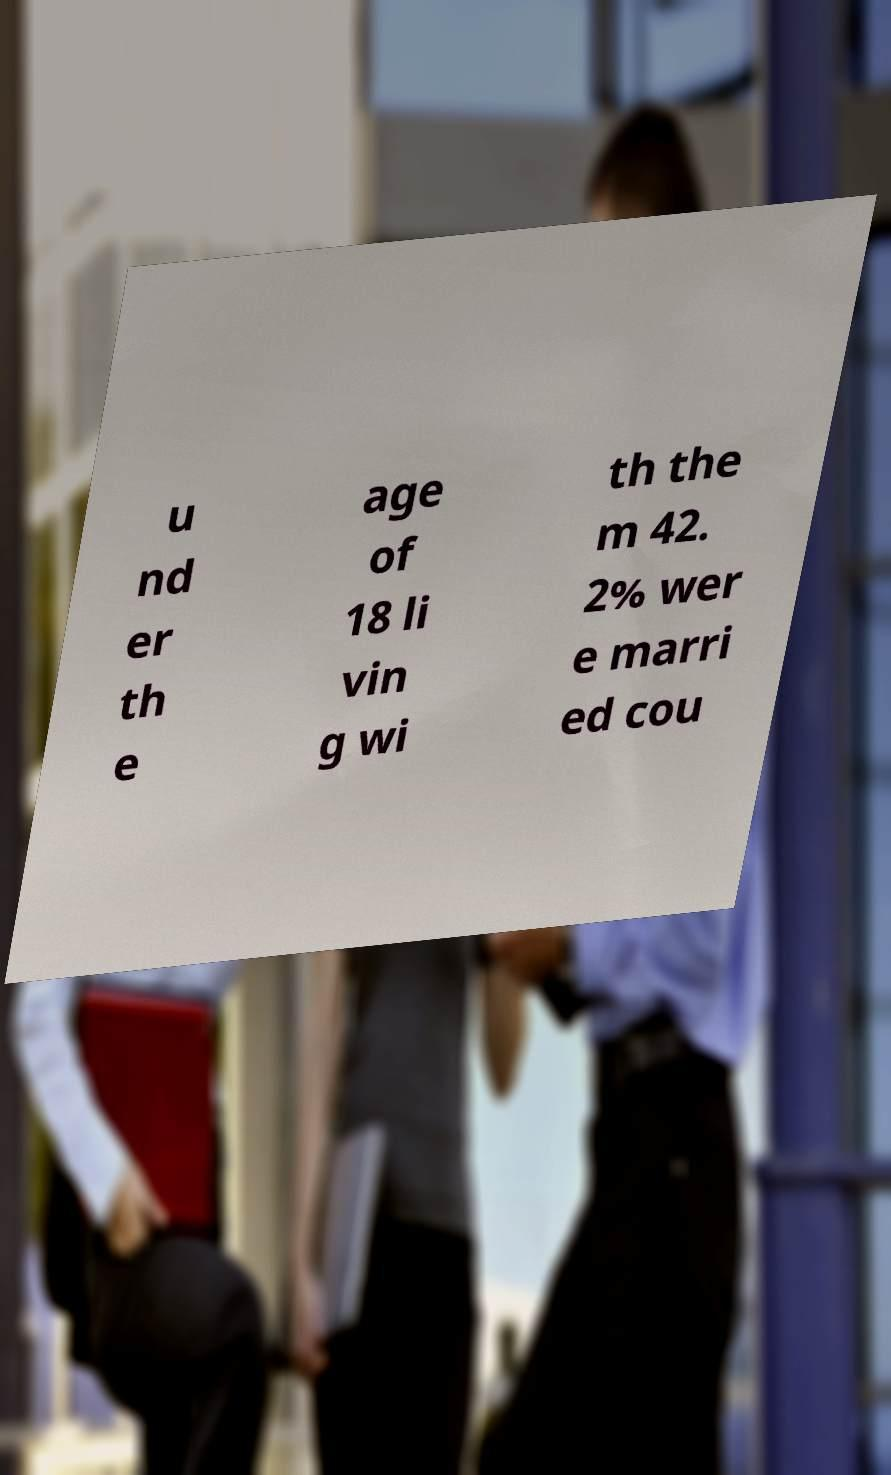There's text embedded in this image that I need extracted. Can you transcribe it verbatim? u nd er th e age of 18 li vin g wi th the m 42. 2% wer e marri ed cou 